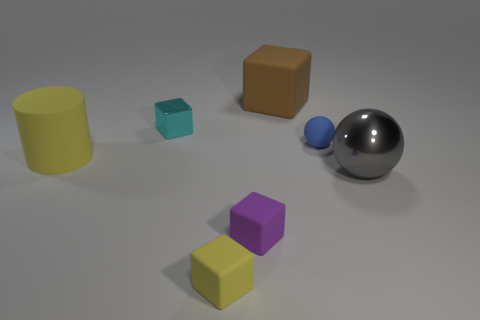How many things are either tiny objects to the left of the large cube or blue things?
Offer a very short reply. 4. How many small cubes are there?
Provide a short and direct response. 3. What shape is the blue thing that is the same material as the purple thing?
Offer a terse response. Sphere. What is the size of the yellow rubber thing that is to the right of the yellow thing that is behind the big gray object?
Offer a very short reply. Small. What number of objects are yellow things behind the big ball or rubber objects to the left of the yellow cube?
Offer a terse response. 1. Is the number of rubber spheres less than the number of metallic objects?
Your response must be concise. Yes. How many objects are either rubber blocks or red metallic cylinders?
Keep it short and to the point. 3. Is the big gray metal object the same shape as the brown matte thing?
Your answer should be compact. No. There is a yellow matte object left of the small cyan object; is it the same size as the shiny thing right of the tiny purple rubber thing?
Keep it short and to the point. Yes. There is a big object that is both to the left of the small blue sphere and to the right of the tiny purple matte object; what material is it?
Your answer should be compact. Rubber. 